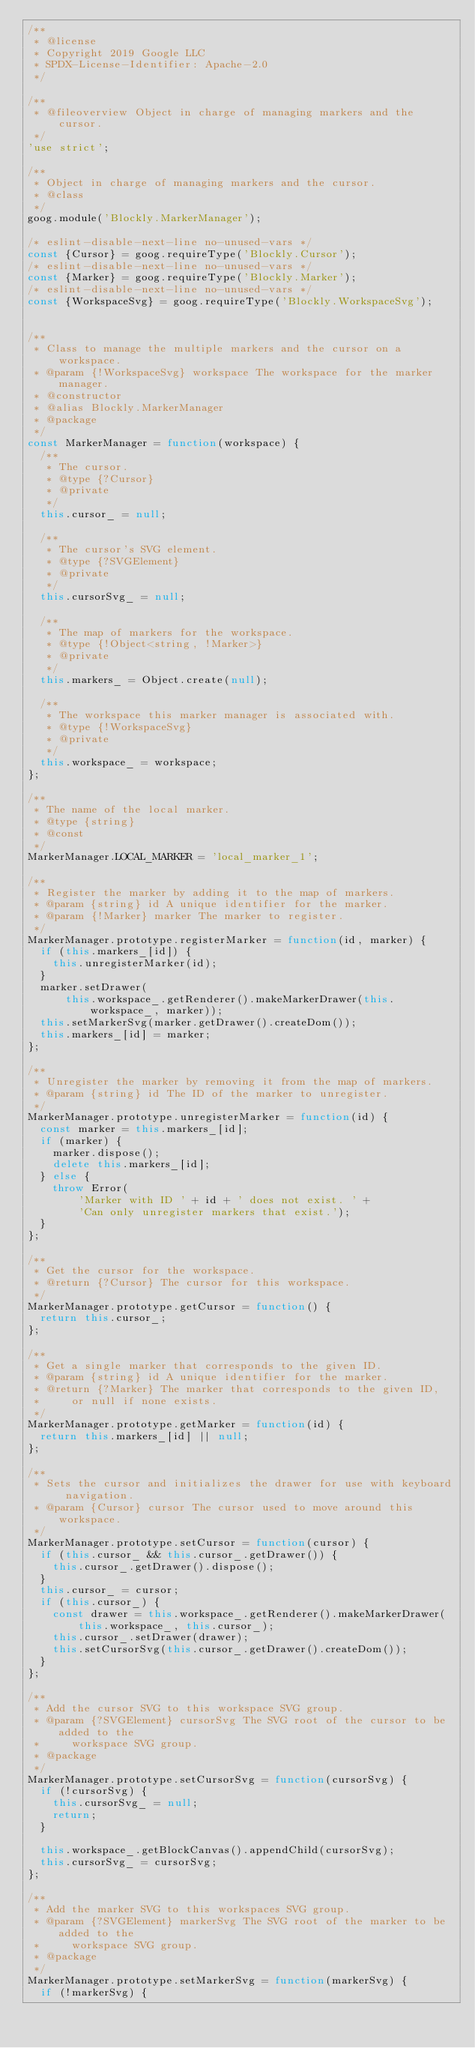Convert code to text. <code><loc_0><loc_0><loc_500><loc_500><_JavaScript_>/**
 * @license
 * Copyright 2019 Google LLC
 * SPDX-License-Identifier: Apache-2.0
 */

/**
 * @fileoverview Object in charge of managing markers and the cursor.
 */
'use strict';

/**
 * Object in charge of managing markers and the cursor.
 * @class
 */
goog.module('Blockly.MarkerManager');

/* eslint-disable-next-line no-unused-vars */
const {Cursor} = goog.requireType('Blockly.Cursor');
/* eslint-disable-next-line no-unused-vars */
const {Marker} = goog.requireType('Blockly.Marker');
/* eslint-disable-next-line no-unused-vars */
const {WorkspaceSvg} = goog.requireType('Blockly.WorkspaceSvg');


/**
 * Class to manage the multiple markers and the cursor on a workspace.
 * @param {!WorkspaceSvg} workspace The workspace for the marker manager.
 * @constructor
 * @alias Blockly.MarkerManager
 * @package
 */
const MarkerManager = function(workspace) {
  /**
   * The cursor.
   * @type {?Cursor}
   * @private
   */
  this.cursor_ = null;

  /**
   * The cursor's SVG element.
   * @type {?SVGElement}
   * @private
   */
  this.cursorSvg_ = null;

  /**
   * The map of markers for the workspace.
   * @type {!Object<string, !Marker>}
   * @private
   */
  this.markers_ = Object.create(null);

  /**
   * The workspace this marker manager is associated with.
   * @type {!WorkspaceSvg}
   * @private
   */
  this.workspace_ = workspace;
};

/**
 * The name of the local marker.
 * @type {string}
 * @const
 */
MarkerManager.LOCAL_MARKER = 'local_marker_1';

/**
 * Register the marker by adding it to the map of markers.
 * @param {string} id A unique identifier for the marker.
 * @param {!Marker} marker The marker to register.
 */
MarkerManager.prototype.registerMarker = function(id, marker) {
  if (this.markers_[id]) {
    this.unregisterMarker(id);
  }
  marker.setDrawer(
      this.workspace_.getRenderer().makeMarkerDrawer(this.workspace_, marker));
  this.setMarkerSvg(marker.getDrawer().createDom());
  this.markers_[id] = marker;
};

/**
 * Unregister the marker by removing it from the map of markers.
 * @param {string} id The ID of the marker to unregister.
 */
MarkerManager.prototype.unregisterMarker = function(id) {
  const marker = this.markers_[id];
  if (marker) {
    marker.dispose();
    delete this.markers_[id];
  } else {
    throw Error(
        'Marker with ID ' + id + ' does not exist. ' +
        'Can only unregister markers that exist.');
  }
};

/**
 * Get the cursor for the workspace.
 * @return {?Cursor} The cursor for this workspace.
 */
MarkerManager.prototype.getCursor = function() {
  return this.cursor_;
};

/**
 * Get a single marker that corresponds to the given ID.
 * @param {string} id A unique identifier for the marker.
 * @return {?Marker} The marker that corresponds to the given ID,
 *     or null if none exists.
 */
MarkerManager.prototype.getMarker = function(id) {
  return this.markers_[id] || null;
};

/**
 * Sets the cursor and initializes the drawer for use with keyboard navigation.
 * @param {Cursor} cursor The cursor used to move around this workspace.
 */
MarkerManager.prototype.setCursor = function(cursor) {
  if (this.cursor_ && this.cursor_.getDrawer()) {
    this.cursor_.getDrawer().dispose();
  }
  this.cursor_ = cursor;
  if (this.cursor_) {
    const drawer = this.workspace_.getRenderer().makeMarkerDrawer(
        this.workspace_, this.cursor_);
    this.cursor_.setDrawer(drawer);
    this.setCursorSvg(this.cursor_.getDrawer().createDom());
  }
};

/**
 * Add the cursor SVG to this workspace SVG group.
 * @param {?SVGElement} cursorSvg The SVG root of the cursor to be added to the
 *     workspace SVG group.
 * @package
 */
MarkerManager.prototype.setCursorSvg = function(cursorSvg) {
  if (!cursorSvg) {
    this.cursorSvg_ = null;
    return;
  }

  this.workspace_.getBlockCanvas().appendChild(cursorSvg);
  this.cursorSvg_ = cursorSvg;
};

/**
 * Add the marker SVG to this workspaces SVG group.
 * @param {?SVGElement} markerSvg The SVG root of the marker to be added to the
 *     workspace SVG group.
 * @package
 */
MarkerManager.prototype.setMarkerSvg = function(markerSvg) {
  if (!markerSvg) {</code> 